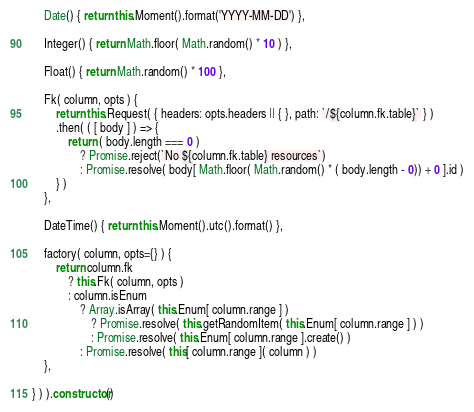<code> <loc_0><loc_0><loc_500><loc_500><_JavaScript_>
    Date() { return this.Moment().format('YYYY-MM-DD') },
    
    Integer() { return Math.floor( Math.random() * 10 ) },
    
    Float() { return Math.random() * 100 },
    
    Fk( column, opts ) {
        return this.Request( { headers: opts.headers || { }, path: `/${column.fk.table}` } )
        .then( ( [ body ] ) => { 
            return ( body.length === 0 )
                ? Promise.reject(`No ${column.fk.table} resources`)
                : Promise.resolve( body[ Math.floor( Math.random() * ( body.length - 0)) + 0 ].id )
        } )
    },
    
    DateTime() { return this.Moment().utc().format() },

    factory( column, opts={} ) {
        return column.fk
            ? this.Fk( column, opts )
            : column.isEnum
                ? Array.isArray( this.Enum[ column.range ] )
                    ? Promise.resolve( this.getRandomItem( this.Enum[ column.range ] ) )
                    : Promise.resolve( this.Enum[ column.range ].create() )
                : Promise.resolve( this[ column.range ]( column ) )
    },

} ) ).constructor()
</code> 